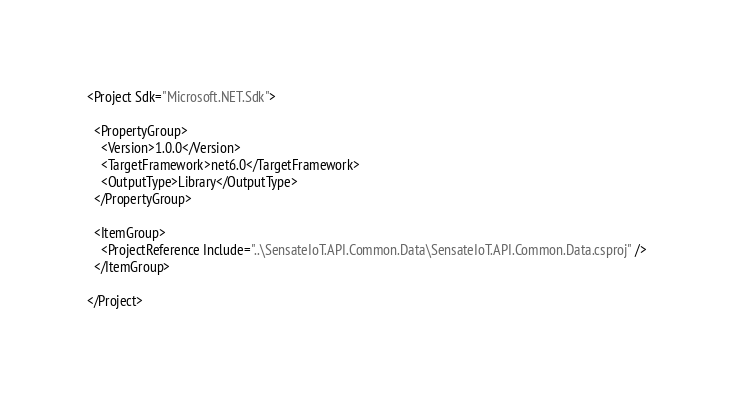Convert code to text. <code><loc_0><loc_0><loc_500><loc_500><_XML_><Project Sdk="Microsoft.NET.Sdk">

  <PropertyGroup>
    <Version>1.0.0</Version>
    <TargetFramework>net6.0</TargetFramework>
    <OutputType>Library</OutputType>
  </PropertyGroup>

  <ItemGroup>
    <ProjectReference Include="..\SensateIoT.API.Common.Data\SensateIoT.API.Common.Data.csproj" />
  </ItemGroup>

</Project>
</code> 